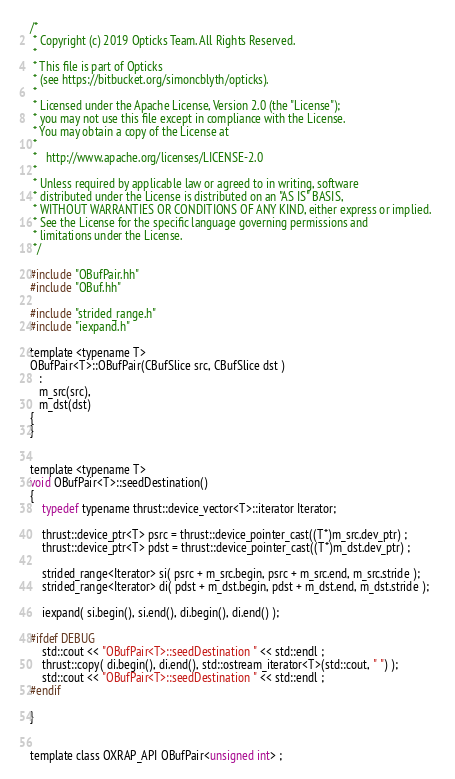Convert code to text. <code><loc_0><loc_0><loc_500><loc_500><_Cuda_>/*
 * Copyright (c) 2019 Opticks Team. All Rights Reserved.
 *
 * This file is part of Opticks
 * (see https://bitbucket.org/simoncblyth/opticks).
 *
 * Licensed under the Apache License, Version 2.0 (the "License"); 
 * you may not use this file except in compliance with the License.  
 * You may obtain a copy of the License at
 *
 *   http://www.apache.org/licenses/LICENSE-2.0
 *
 * Unless required by applicable law or agreed to in writing, software 
 * distributed under the License is distributed on an "AS IS" BASIS, 
 * WITHOUT WARRANTIES OR CONDITIONS OF ANY KIND, either express or implied.  
 * See the License for the specific language governing permissions and 
 * limitations under the License.
 */

#include "OBufPair.hh"
#include "OBuf.hh"

#include "strided_range.h"
#include "iexpand.h"

template <typename T>
OBufPair<T>::OBufPair(CBufSlice src, CBufSlice dst ) 
   :
   m_src(src),
   m_dst(dst)
{
}


template <typename T>
void OBufPair<T>::seedDestination()
{
    typedef typename thrust::device_vector<T>::iterator Iterator;

    thrust::device_ptr<T> psrc = thrust::device_pointer_cast((T*)m_src.dev_ptr) ; 
    thrust::device_ptr<T> pdst = thrust::device_pointer_cast((T*)m_dst.dev_ptr) ; 

    strided_range<Iterator> si( psrc + m_src.begin, psrc + m_src.end, m_src.stride );
    strided_range<Iterator> di( pdst + m_dst.begin, pdst + m_dst.end, m_dst.stride );

    iexpand( si.begin(), si.end(), di.begin(), di.end() );

#ifdef DEBUG
    std::cout << "OBufPair<T>::seedDestination " << std::endl ; 
    thrust::copy( di.begin(), di.end(), std::ostream_iterator<T>(std::cout, " ") ); 
    std::cout << "OBufPair<T>::seedDestination " << std::endl ; 
#endif

}


template class OXRAP_API OBufPair<unsigned int> ;

</code> 